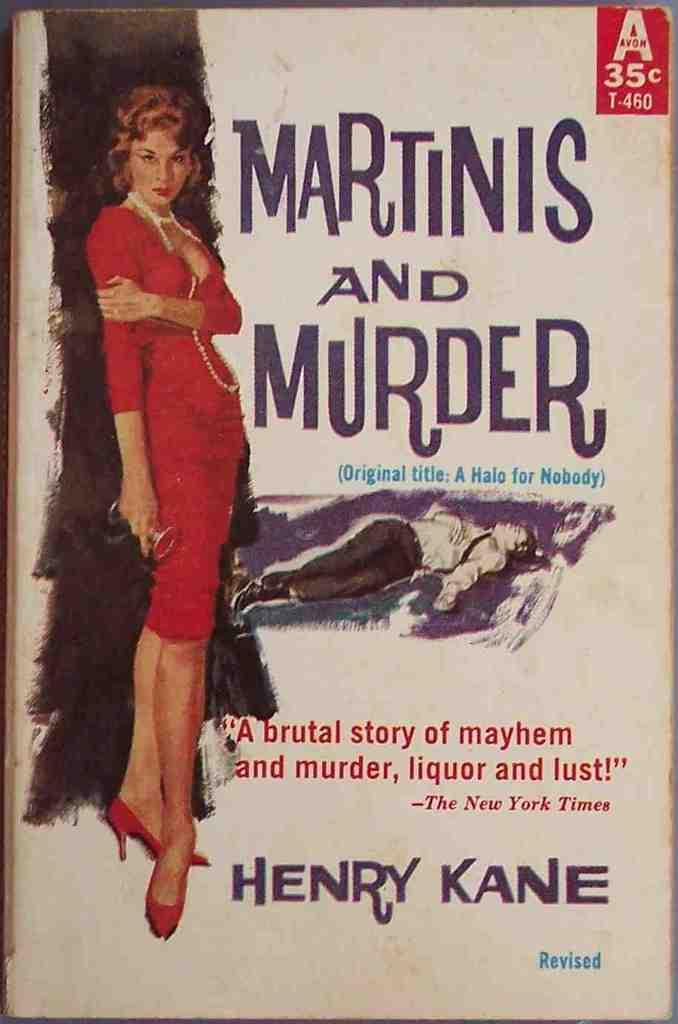<image>
Summarize the visual content of the image. An old book that cost 35 cents titled Martinis and Murder. 